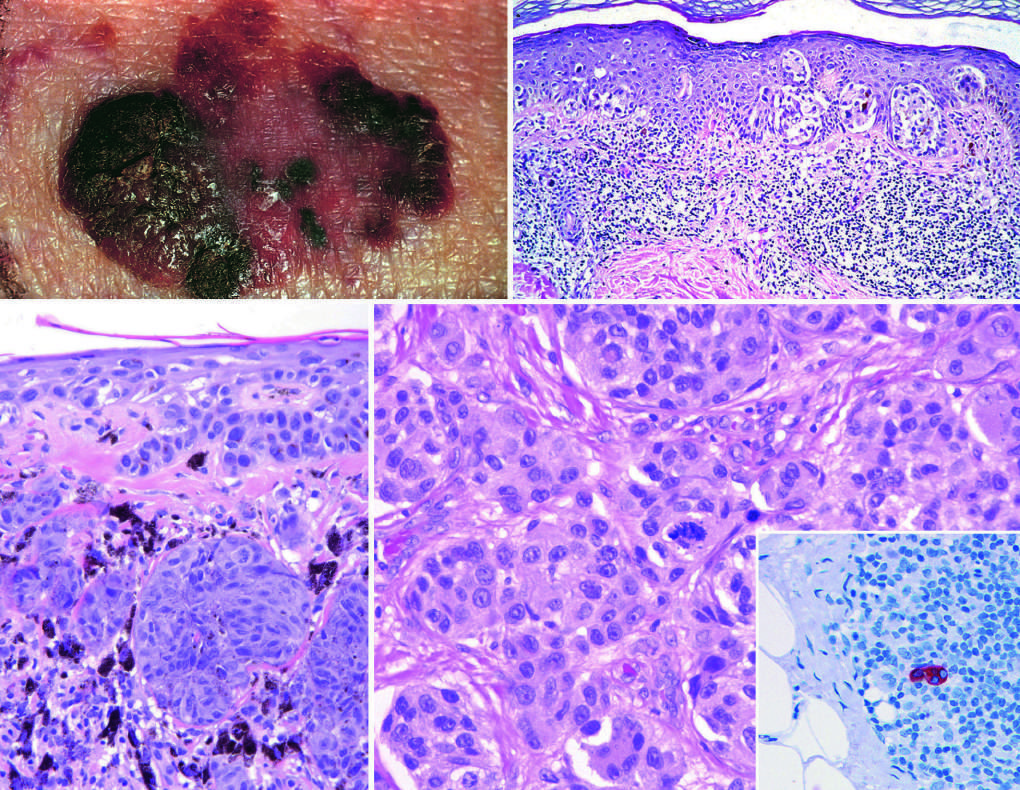what shows a sentinel lymph node containing a tiny cluster of metastatic melanoma, detected by staining for the melanocytic marker hmb-45?
Answer the question using a single word or phrase. The inset 